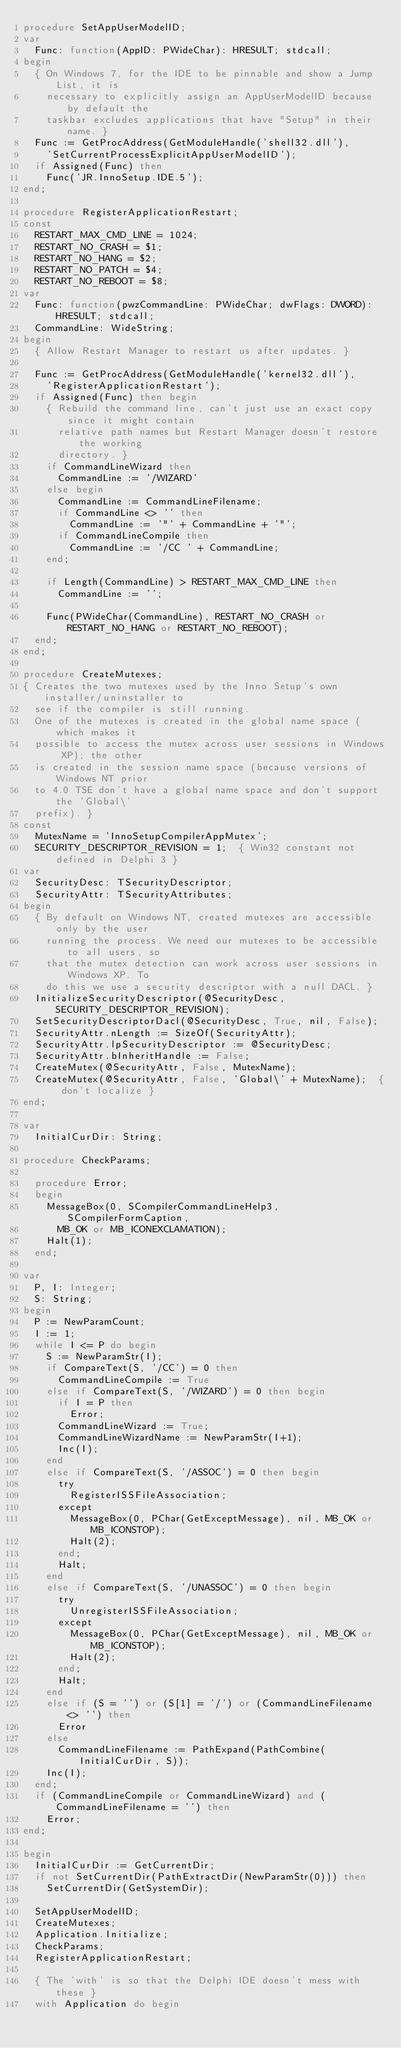Convert code to text. <code><loc_0><loc_0><loc_500><loc_500><_Pascal_>procedure SetAppUserModelID;
var
  Func: function(AppID: PWideChar): HRESULT; stdcall;
begin
  { On Windows 7, for the IDE to be pinnable and show a Jump List, it is
    necessary to explicitly assign an AppUserModelID because by default the
    taskbar excludes applications that have "Setup" in their name. }
  Func := GetProcAddress(GetModuleHandle('shell32.dll'),
    'SetCurrentProcessExplicitAppUserModelID');
  if Assigned(Func) then
    Func('JR.InnoSetup.IDE.5');
end;

procedure RegisterApplicationRestart;
const
  RESTART_MAX_CMD_LINE = 1024;
  RESTART_NO_CRASH = $1;
  RESTART_NO_HANG = $2;
  RESTART_NO_PATCH = $4;
  RESTART_NO_REBOOT = $8;
var
  Func: function(pwzCommandLine: PWideChar; dwFlags: DWORD): HRESULT; stdcall;
  CommandLine: WideString;
begin
  { Allow Restart Manager to restart us after updates. }

  Func := GetProcAddress(GetModuleHandle('kernel32.dll'),
    'RegisterApplicationRestart');
  if Assigned(Func) then begin
    { Rebuild the command line, can't just use an exact copy since it might contain
      relative path names but Restart Manager doesn't restore the working
      directory. }
    if CommandLineWizard then
      CommandLine := '/WIZARD'
    else begin
      CommandLine := CommandLineFilename;
      if CommandLine <> '' then
        CommandLine := '"' + CommandLine + '"';
      if CommandLineCompile then
        CommandLine := '/CC ' + CommandLine;
    end;
    
    if Length(CommandLine) > RESTART_MAX_CMD_LINE then
      CommandLine := '';

    Func(PWideChar(CommandLine), RESTART_NO_CRASH or RESTART_NO_HANG or RESTART_NO_REBOOT);
  end;
end;

procedure CreateMutexes;
{ Creates the two mutexes used by the Inno Setup's own installer/uninstaller to
  see if the compiler is still running.
  One of the mutexes is created in the global name space (which makes it
  possible to access the mutex across user sessions in Windows XP); the other
  is created in the session name space (because versions of Windows NT prior
  to 4.0 TSE don't have a global name space and don't support the 'Global\'
  prefix). }
const
  MutexName = 'InnoSetupCompilerAppMutex';
  SECURITY_DESCRIPTOR_REVISION = 1;  { Win32 constant not defined in Delphi 3 }
var
  SecurityDesc: TSecurityDescriptor;
  SecurityAttr: TSecurityAttributes;
begin
  { By default on Windows NT, created mutexes are accessible only by the user
    running the process. We need our mutexes to be accessible to all users, so
    that the mutex detection can work across user sessions in Windows XP. To
    do this we use a security descriptor with a null DACL. }
  InitializeSecurityDescriptor(@SecurityDesc, SECURITY_DESCRIPTOR_REVISION);
  SetSecurityDescriptorDacl(@SecurityDesc, True, nil, False);
  SecurityAttr.nLength := SizeOf(SecurityAttr);
  SecurityAttr.lpSecurityDescriptor := @SecurityDesc;
  SecurityAttr.bInheritHandle := False;
  CreateMutex(@SecurityAttr, False, MutexName);
  CreateMutex(@SecurityAttr, False, 'Global\' + MutexName);  { don't localize }
end;

var
  InitialCurDir: String;

procedure CheckParams;

  procedure Error;
  begin
    MessageBox(0, SCompilerCommandLineHelp3, SCompilerFormCaption,
      MB_OK or MB_ICONEXCLAMATION);
    Halt(1);
  end;

var
  P, I: Integer;
  S: String;
begin
  P := NewParamCount;
  I := 1;
  while I <= P do begin
    S := NewParamStr(I);
    if CompareText(S, '/CC') = 0 then
      CommandLineCompile := True
    else if CompareText(S, '/WIZARD') = 0 then begin
      if I = P then
        Error;
      CommandLineWizard := True;
      CommandLineWizardName := NewParamStr(I+1);
      Inc(I);
    end
    else if CompareText(S, '/ASSOC') = 0 then begin
      try
        RegisterISSFileAssociation;
      except
        MessageBox(0, PChar(GetExceptMessage), nil, MB_OK or MB_ICONSTOP);
        Halt(2);
      end;
      Halt;
    end
    else if CompareText(S, '/UNASSOC') = 0 then begin
      try
        UnregisterISSFileAssociation;
      except
        MessageBox(0, PChar(GetExceptMessage), nil, MB_OK or MB_ICONSTOP);
        Halt(2);
      end;
      Halt;
    end
    else if (S = '') or (S[1] = '/') or (CommandLineFilename <> '') then
      Error
    else
      CommandLineFilename := PathExpand(PathCombine(InitialCurDir, S));
    Inc(I);
  end;
  if (CommandLineCompile or CommandLineWizard) and (CommandLineFilename = '') then
    Error;
end;

begin
  InitialCurDir := GetCurrentDir;
  if not SetCurrentDir(PathExtractDir(NewParamStr(0))) then
    SetCurrentDir(GetSystemDir);

  SetAppUserModelID;
  CreateMutexes;
  Application.Initialize;
  CheckParams;
  RegisterApplicationRestart;

  { The 'with' is so that the Delphi IDE doesn't mess with these }
  with Application do begin</code> 